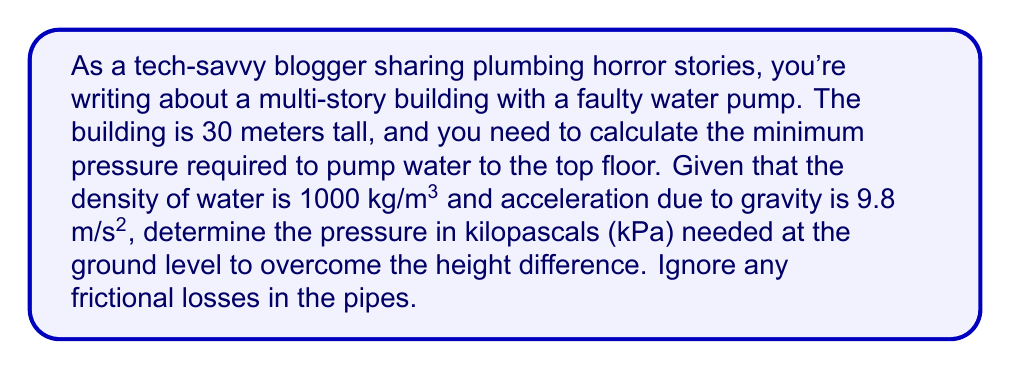Teach me how to tackle this problem. To solve this problem, we'll use the hydrostatic pressure equation:

$$P = \rho gh$$

Where:
$P$ = Pressure (Pa)
$\rho$ (rho) = Density of water (kg/m³)
$g$ = Acceleration due to gravity (m/s²)
$h$ = Height difference (m)

Given:
- Height of the building, $h = 30$ m
- Density of water, $\rho = 1000$ kg/m³
- Acceleration due to gravity, $g = 9.8$ m/s²

Step 1: Substitute the values into the equation:
$$P = 1000 \text{ kg/m³} \times 9.8 \text{ m/s²} \times 30 \text{ m}$$

Step 2: Calculate the pressure:
$$P = 294,000 \text{ Pa}$$

Step 3: Convert pascals (Pa) to kilopascals (kPa):
$$P = 294,000 \text{ Pa} \times \frac{1 \text{ kPa}}{1000 \text{ Pa}} = 294 \text{ kPa}$$

Therefore, the minimum pressure required at ground level to pump water to the top floor of the 30-meter building is 294 kPa.
Answer: 294 kPa 